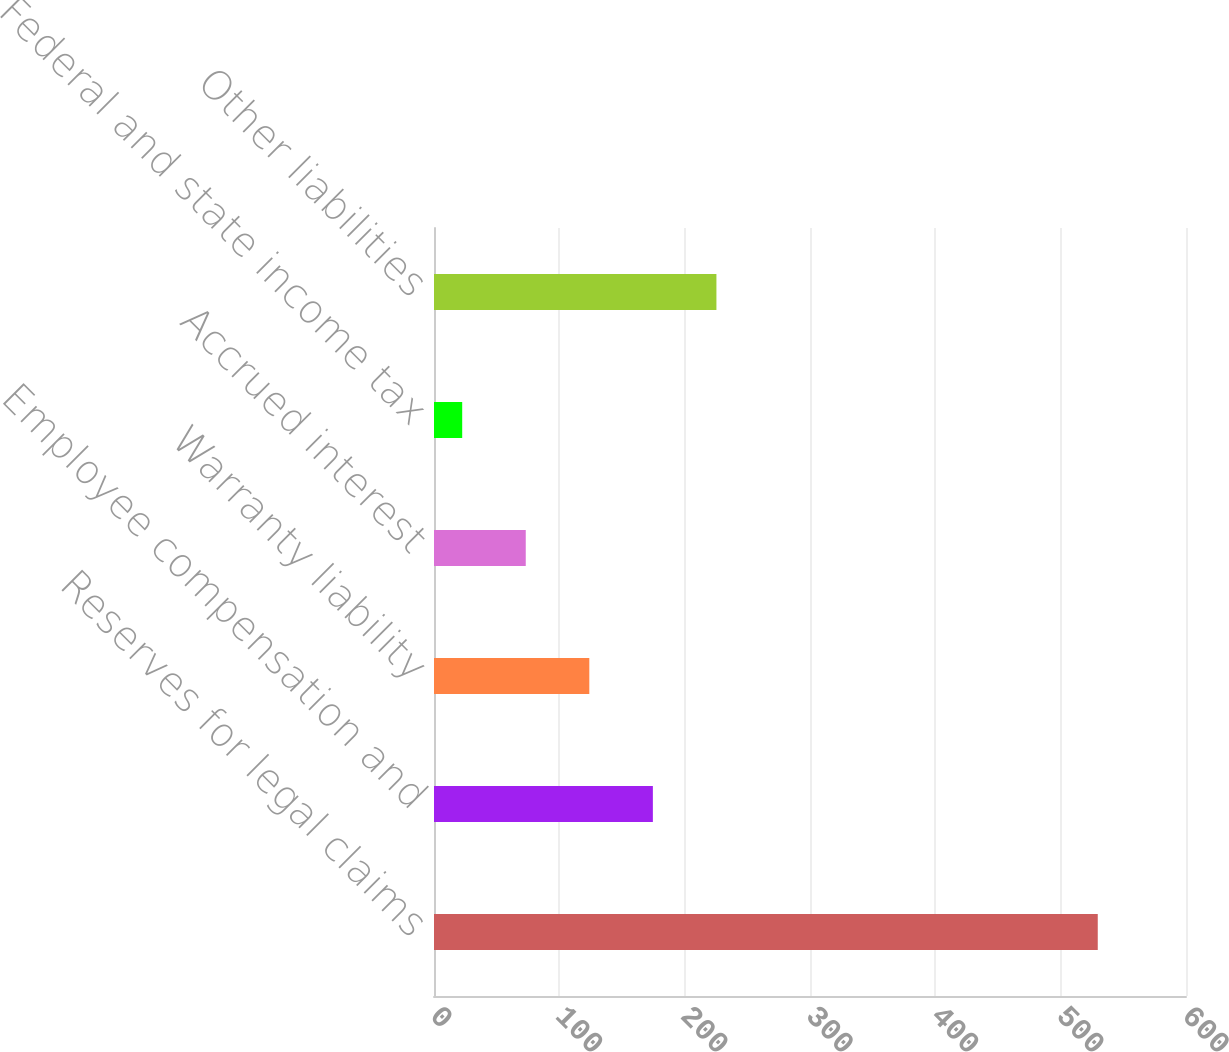Convert chart. <chart><loc_0><loc_0><loc_500><loc_500><bar_chart><fcel>Reserves for legal claims<fcel>Employee compensation and<fcel>Warranty liability<fcel>Accrued interest<fcel>Federal and state income tax<fcel>Other liabilities<nl><fcel>529.6<fcel>174.63<fcel>123.92<fcel>73.21<fcel>22.5<fcel>225.34<nl></chart> 